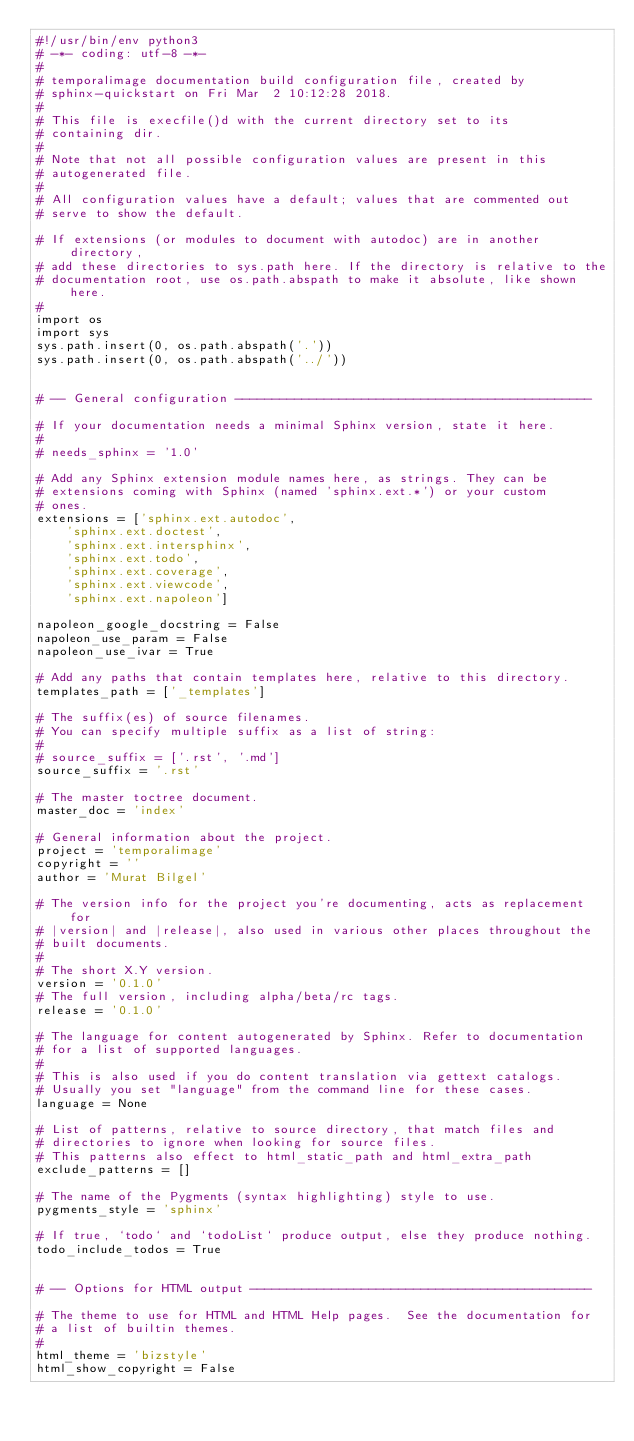<code> <loc_0><loc_0><loc_500><loc_500><_Python_>#!/usr/bin/env python3
# -*- coding: utf-8 -*-
#
# temporalimage documentation build configuration file, created by
# sphinx-quickstart on Fri Mar  2 10:12:28 2018.
#
# This file is execfile()d with the current directory set to its
# containing dir.
#
# Note that not all possible configuration values are present in this
# autogenerated file.
#
# All configuration values have a default; values that are commented out
# serve to show the default.

# If extensions (or modules to document with autodoc) are in another directory,
# add these directories to sys.path here. If the directory is relative to the
# documentation root, use os.path.abspath to make it absolute, like shown here.
#
import os
import sys
sys.path.insert(0, os.path.abspath('.'))
sys.path.insert(0, os.path.abspath('../'))


# -- General configuration ------------------------------------------------

# If your documentation needs a minimal Sphinx version, state it here.
#
# needs_sphinx = '1.0'

# Add any Sphinx extension module names here, as strings. They can be
# extensions coming with Sphinx (named 'sphinx.ext.*') or your custom
# ones.
extensions = ['sphinx.ext.autodoc',
    'sphinx.ext.doctest',
    'sphinx.ext.intersphinx',
    'sphinx.ext.todo',
    'sphinx.ext.coverage',
    'sphinx.ext.viewcode',
    'sphinx.ext.napoleon']

napoleon_google_docstring = False
napoleon_use_param = False
napoleon_use_ivar = True

# Add any paths that contain templates here, relative to this directory.
templates_path = ['_templates']

# The suffix(es) of source filenames.
# You can specify multiple suffix as a list of string:
#
# source_suffix = ['.rst', '.md']
source_suffix = '.rst'

# The master toctree document.
master_doc = 'index'

# General information about the project.
project = 'temporalimage'
copyright = ''
author = 'Murat Bilgel'

# The version info for the project you're documenting, acts as replacement for
# |version| and |release|, also used in various other places throughout the
# built documents.
#
# The short X.Y version.
version = '0.1.0'
# The full version, including alpha/beta/rc tags.
release = '0.1.0'

# The language for content autogenerated by Sphinx. Refer to documentation
# for a list of supported languages.
#
# This is also used if you do content translation via gettext catalogs.
# Usually you set "language" from the command line for these cases.
language = None

# List of patterns, relative to source directory, that match files and
# directories to ignore when looking for source files.
# This patterns also effect to html_static_path and html_extra_path
exclude_patterns = []

# The name of the Pygments (syntax highlighting) style to use.
pygments_style = 'sphinx'

# If true, `todo` and `todoList` produce output, else they produce nothing.
todo_include_todos = True


# -- Options for HTML output ----------------------------------------------

# The theme to use for HTML and HTML Help pages.  See the documentation for
# a list of builtin themes.
#
html_theme = 'bizstyle'
html_show_copyright = False
</code> 